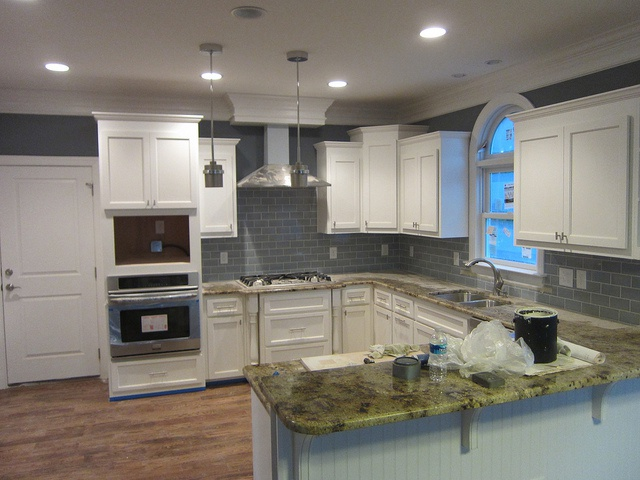Describe the objects in this image and their specific colors. I can see oven in gray, black, and darkgray tones, bottle in gray, darkgray, and navy tones, and sink in gray, black, and darkgray tones in this image. 